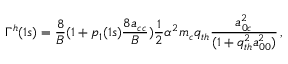Convert formula to latex. <formula><loc_0><loc_0><loc_500><loc_500>\Gamma ^ { h } ( 1 s ) = \frac { 8 } { B } ( 1 + p _ { 1 } ( 1 s ) \frac { 8 a _ { c c } } { B } ) \frac { 1 } { 2 } \alpha ^ { 2 } m _ { c } q _ { t h } \frac { a _ { 0 c } ^ { 2 } } { ( 1 + q _ { t h } ^ { 2 } a _ { 0 0 } ^ { 2 } ) } \, ,</formula> 